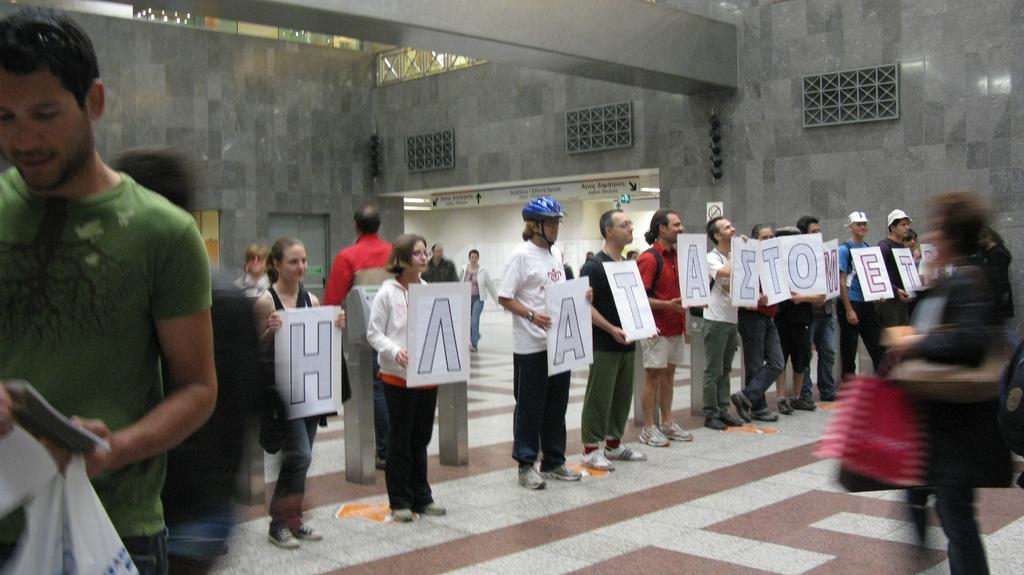What are the people in the image holding? The people in the image are holding boards with text. What can be seen on the boards? The text is written on the boards. What is visible in the background of the image? There is a wall visible in the background of the image. What type of fowl can be seen eating a meal in the image? There is no fowl or meal present in the image; it features people holding boards with text. What is the people's desire in the image? The image does not convey any specific desires of the people; it only shows them holding boards with text. 